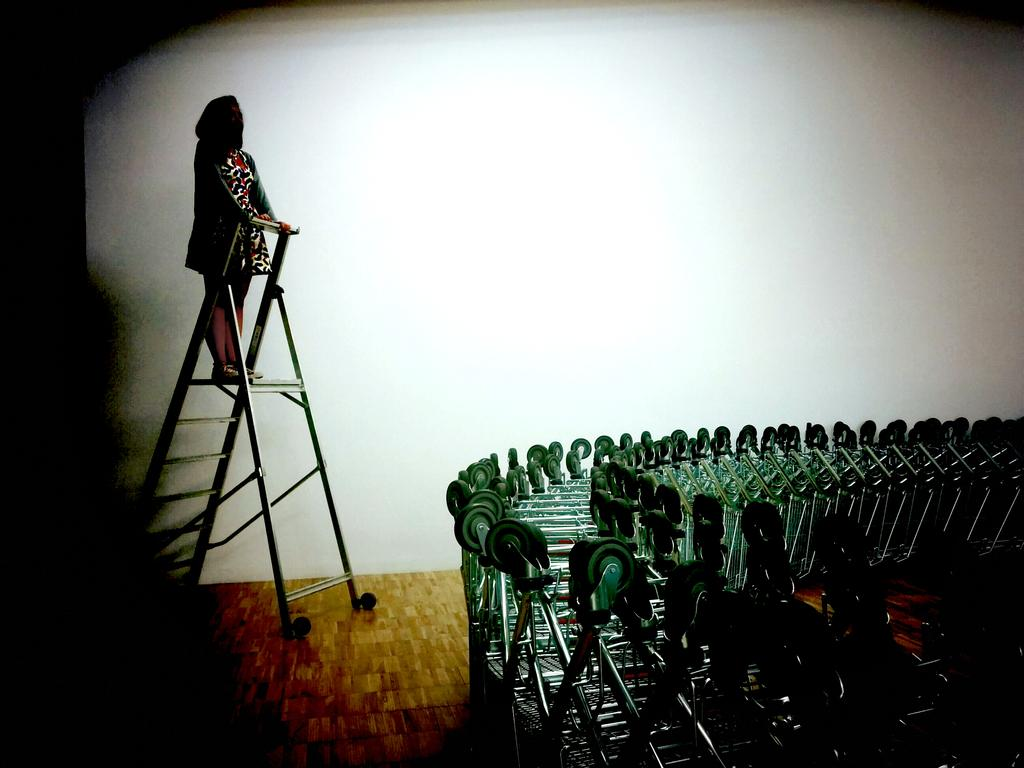Who is the main subject in the image? There is a woman in the image. What is the woman doing in the image? The woman is standing on a ladder. What else can be seen on the floor in the image? There are trolleys on the floor in the image. What does the woman's mouth look like in the image? The provided facts do not mention the woman's mouth, so we cannot determine what it looks like from the image. 